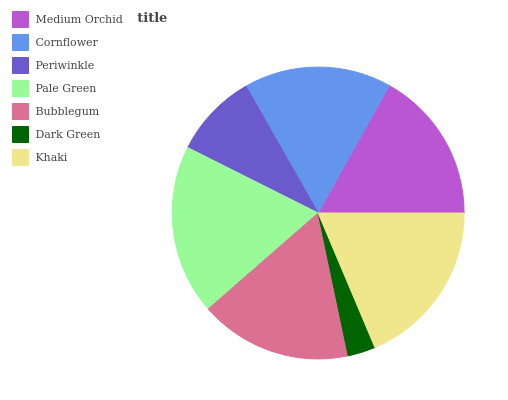Is Dark Green the minimum?
Answer yes or no. Yes. Is Pale Green the maximum?
Answer yes or no. Yes. Is Cornflower the minimum?
Answer yes or no. No. Is Cornflower the maximum?
Answer yes or no. No. Is Medium Orchid greater than Cornflower?
Answer yes or no. Yes. Is Cornflower less than Medium Orchid?
Answer yes or no. Yes. Is Cornflower greater than Medium Orchid?
Answer yes or no. No. Is Medium Orchid less than Cornflower?
Answer yes or no. No. Is Bubblegum the high median?
Answer yes or no. Yes. Is Bubblegum the low median?
Answer yes or no. Yes. Is Medium Orchid the high median?
Answer yes or no. No. Is Periwinkle the low median?
Answer yes or no. No. 